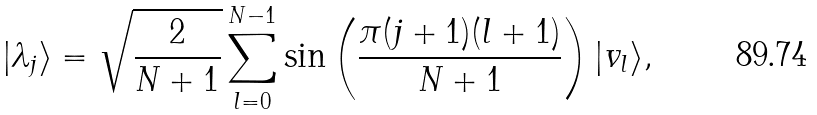Convert formula to latex. <formula><loc_0><loc_0><loc_500><loc_500>| \lambda _ { j } \rangle = \sqrt { \frac { 2 } { N + 1 } } \sum _ { l = 0 } ^ { N - 1 } \sin \left ( \frac { \pi ( j + 1 ) ( l + 1 ) } { N + 1 } \right ) | v _ { l } \rangle ,</formula> 